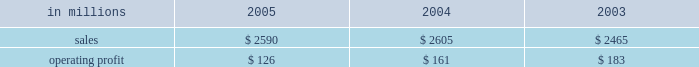Entering 2006 , industrial packaging earnings are expected to improve significantly in the first quarter compared with the fourth quarter 2005 .
Average price realizations should continue to benefit from price in- creases announced in late 2005 and early 2006 for linerboard and domestic boxes .
Containerboard sales volumes are expected to drop slightly in the 2006 first quarter due to fewer shipping days , but growth is antici- pated for u.s .
Converted products due to stronger de- mand .
Costs for wood , freight and energy are expected to remain stable during the 2006 first quarter , approach- ing fourth quarter 2005 levels .
The continued im- plementation of the new supply chain model at our mills during 2006 will bring additional efficiency improve- ments and cost savings .
On a global basis , the european container operating results are expected to improve as a result of targeted market growth and cost reduction ini- tiatives , and we will begin seeing further contributions from our recent moroccan box plant acquisition and from international paper distribution limited .
Consumer packaging demand and pricing for consumer packaging prod- ucts correlate closely with consumer spending and gen- eral economic activity .
In addition to prices and volumes , major factors affecting the profitability of con- sumer packaging are raw material and energy costs , manufacturing efficiency and product mix .
Consumer packaging 2019s 2005 net sales of $ 2.6 bil- lion were flat compared with 2004 and 5% ( 5 % ) higher com- pared with 2003 .
Operating profits in 2005 declined 22% ( 22 % ) from 2004 and 31% ( 31 % ) from 2003 as improved price realizations ( $ 46 million ) and favorable operations in the mills and converting operations ( $ 60 million ) could not overcome the impact of cost increases in energy , wood , polyethylene and other raw materials ( $ 120 million ) , lack-of-order downtime ( $ 13 million ) and other costs ( $ 8 million ) .
Consumer packaging in millions 2005 2004 2003 .
Bleached board net sales of $ 864 million in 2005 were up from $ 842 million in 2004 and $ 751 million in 2003 .
The effects in 2005 of improved average price realizations and mill operating improvements were not enough to offset increased energy , wood , polyethylene and other raw material costs , a slight decrease in volume and increased lack-of-order downtime .
Bleached board mills took 100000 tons of downtime in 2005 , including 65000 tons of lack-of-order downtime , compared with 40000 tons of downtime in 2004 , none of which was market related .
During 2005 , restructuring and manufacturing improvement plans were implemented to reduce costs and improve market alignment .
Foodservice net sales were $ 437 million in 2005 compared with $ 480 million in 2004 and $ 460 million in 2003 .
Average sales prices in 2005 were up 3% ( 3 % ) ; how- ever , domestic cup and lid sales volumes were 5% ( 5 % ) lower than in 2004 as a result of a rationalization of our cus- tomer base early in 2005 .
Operating profits in 2005 in- creased 147% ( 147 % ) compared with 2004 , largely due to the settlement of a lawsuit and a favorable adjustment on the sale of the jackson , tennessee bag plant .
Excluding unusual items , operating profits were flat as improved price realizations offset increased costs for bleached board and resin .
Shorewood net sales of $ 691 million in 2005 were essentially flat with net sales in 2004 of $ 687 million , but were up compared with $ 665 million in 2003 .
Operating profits in 2005 were 17% ( 17 % ) above 2004 levels and about equal to 2003 levels .
Improved margins resulting from a rationalization of the customer mix and the effects of improved manufacturing operations , including the successful start up of our south korean tobacco operations , more than offset cost increases for board and paper and the impact of unfavorable foreign exchange rates in canada .
Beverage packaging net sales were $ 597 million in 2005 , $ 595 million in 2004 and $ 589 million in 2003 .
Average sale price realizations increased 2% ( 2 % ) compared with 2004 , principally the result of the pass-through of higher raw material costs , although the implementation of price increases continues to be impacted by com- petitive pressures .
Operating profits were down 14% ( 14 % ) compared with 2004 and 19% ( 19 % ) compared with 2003 , due principally to increases in board and resin costs .
In 2006 , the bleached board market is expected to remain strong , with sales volumes increasing in the first quarter compared with the fourth quarter of 2005 for both folding carton and cup products .
Improved price realizations are also expected for bleached board and in our foodservice and beverage packaging businesses , al- though continued high costs for energy , wood and resin will continue to negatively impact earnings .
Shorewood should continue to benefit from strong asian operations and from targeted sales volume growth in 2006 .
Capital improvements and operational excellence initiatives undertaken in 2005 should benefit operating results in 2006 for all businesses .
Distribution our distribution business , principally represented by our xpedx business , markets a diverse array of products and supply chain services to customers in many business segments .
Customer demand is generally sensitive to changes in general economic conditions , although the .
What was the consumer packaging profit margin in 2003? 
Computations: (183 / 2465)
Answer: 0.07424. 